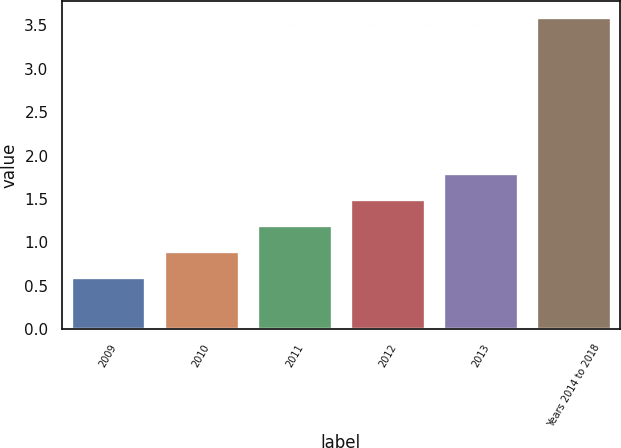<chart> <loc_0><loc_0><loc_500><loc_500><bar_chart><fcel>2009<fcel>2010<fcel>2011<fcel>2012<fcel>2013<fcel>Years 2014 to 2018<nl><fcel>0.6<fcel>0.9<fcel>1.2<fcel>1.5<fcel>1.8<fcel>3.6<nl></chart> 